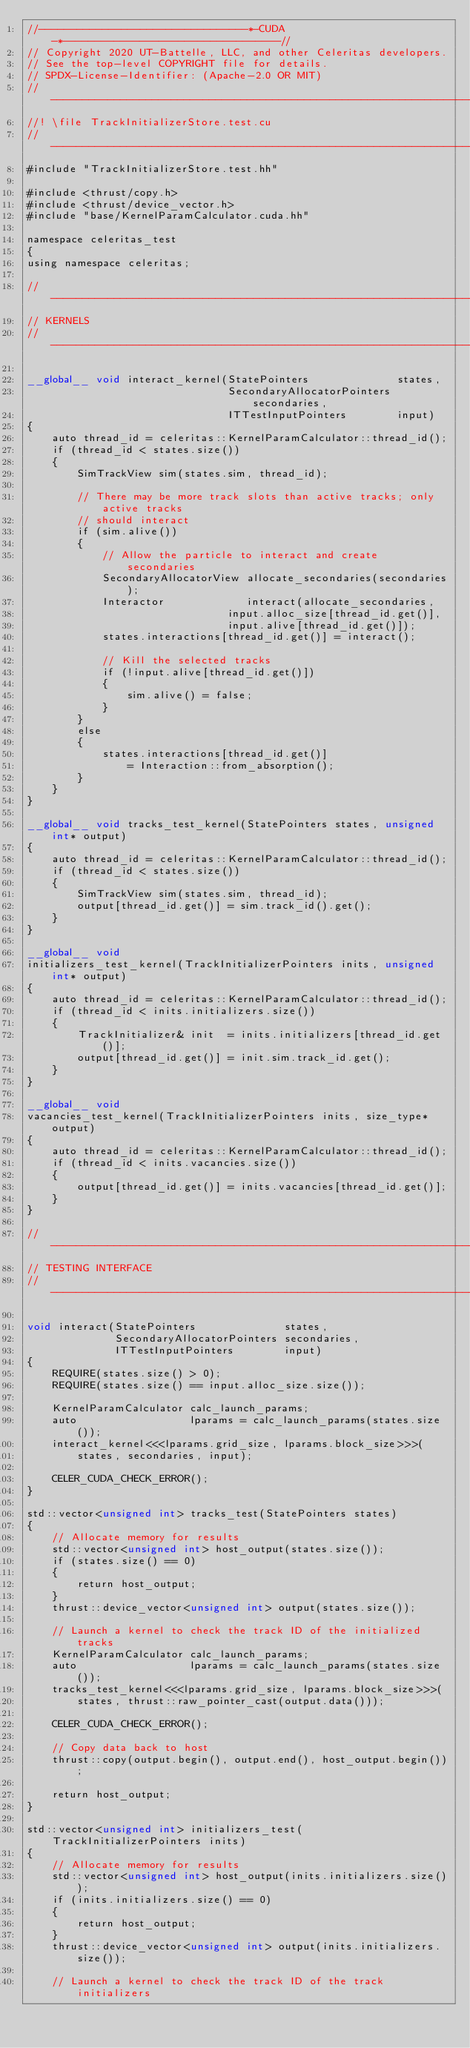<code> <loc_0><loc_0><loc_500><loc_500><_Cuda_>//---------------------------------*-CUDA-*----------------------------------//
// Copyright 2020 UT-Battelle, LLC, and other Celeritas developers.
// See the top-level COPYRIGHT file for details.
// SPDX-License-Identifier: (Apache-2.0 OR MIT)
//---------------------------------------------------------------------------//
//! \file TrackInitializerStore.test.cu
//---------------------------------------------------------------------------//
#include "TrackInitializerStore.test.hh"

#include <thrust/copy.h>
#include <thrust/device_vector.h>
#include "base/KernelParamCalculator.cuda.hh"

namespace celeritas_test
{
using namespace celeritas;

//---------------------------------------------------------------------------//
// KERNELS
//---------------------------------------------------------------------------//

__global__ void interact_kernel(StatePointers              states,
                                SecondaryAllocatorPointers secondaries,
                                ITTestInputPointers        input)
{
    auto thread_id = celeritas::KernelParamCalculator::thread_id();
    if (thread_id < states.size())
    {
        SimTrackView sim(states.sim, thread_id);

        // There may be more track slots than active tracks; only active tracks
        // should interact
        if (sim.alive())
        {
            // Allow the particle to interact and create secondaries
            SecondaryAllocatorView allocate_secondaries(secondaries);
            Interactor             interact(allocate_secondaries,
                                input.alloc_size[thread_id.get()],
                                input.alive[thread_id.get()]);
            states.interactions[thread_id.get()] = interact();

            // Kill the selected tracks
            if (!input.alive[thread_id.get()])
            {
                sim.alive() = false;
            }
        }
        else
        {
            states.interactions[thread_id.get()]
                = Interaction::from_absorption();
        }
    }
}

__global__ void tracks_test_kernel(StatePointers states, unsigned int* output)
{
    auto thread_id = celeritas::KernelParamCalculator::thread_id();
    if (thread_id < states.size())
    {
        SimTrackView sim(states.sim, thread_id);
        output[thread_id.get()] = sim.track_id().get();
    }
}

__global__ void
initializers_test_kernel(TrackInitializerPointers inits, unsigned int* output)
{
    auto thread_id = celeritas::KernelParamCalculator::thread_id();
    if (thread_id < inits.initializers.size())
    {
        TrackInitializer& init  = inits.initializers[thread_id.get()];
        output[thread_id.get()] = init.sim.track_id.get();
    }
}

__global__ void
vacancies_test_kernel(TrackInitializerPointers inits, size_type* output)
{
    auto thread_id = celeritas::KernelParamCalculator::thread_id();
    if (thread_id < inits.vacancies.size())
    {
        output[thread_id.get()] = inits.vacancies[thread_id.get()];
    }
}

//---------------------------------------------------------------------------//
// TESTING INTERFACE
//---------------------------------------------------------------------------//

void interact(StatePointers              states,
              SecondaryAllocatorPointers secondaries,
              ITTestInputPointers        input)
{
    REQUIRE(states.size() > 0);
    REQUIRE(states.size() == input.alloc_size.size());

    KernelParamCalculator calc_launch_params;
    auto                  lparams = calc_launch_params(states.size());
    interact_kernel<<<lparams.grid_size, lparams.block_size>>>(
        states, secondaries, input);

    CELER_CUDA_CHECK_ERROR();
}

std::vector<unsigned int> tracks_test(StatePointers states)
{
    // Allocate memory for results
    std::vector<unsigned int> host_output(states.size());
    if (states.size() == 0)
    {
        return host_output;
    }
    thrust::device_vector<unsigned int> output(states.size());

    // Launch a kernel to check the track ID of the initialized tracks
    KernelParamCalculator calc_launch_params;
    auto                  lparams = calc_launch_params(states.size());
    tracks_test_kernel<<<lparams.grid_size, lparams.block_size>>>(
        states, thrust::raw_pointer_cast(output.data()));

    CELER_CUDA_CHECK_ERROR();

    // Copy data back to host
    thrust::copy(output.begin(), output.end(), host_output.begin());

    return host_output;
}

std::vector<unsigned int> initializers_test(TrackInitializerPointers inits)
{
    // Allocate memory for results
    std::vector<unsigned int> host_output(inits.initializers.size());
    if (inits.initializers.size() == 0)
    {
        return host_output;
    }
    thrust::device_vector<unsigned int> output(inits.initializers.size());

    // Launch a kernel to check the track ID of the track initializers</code> 